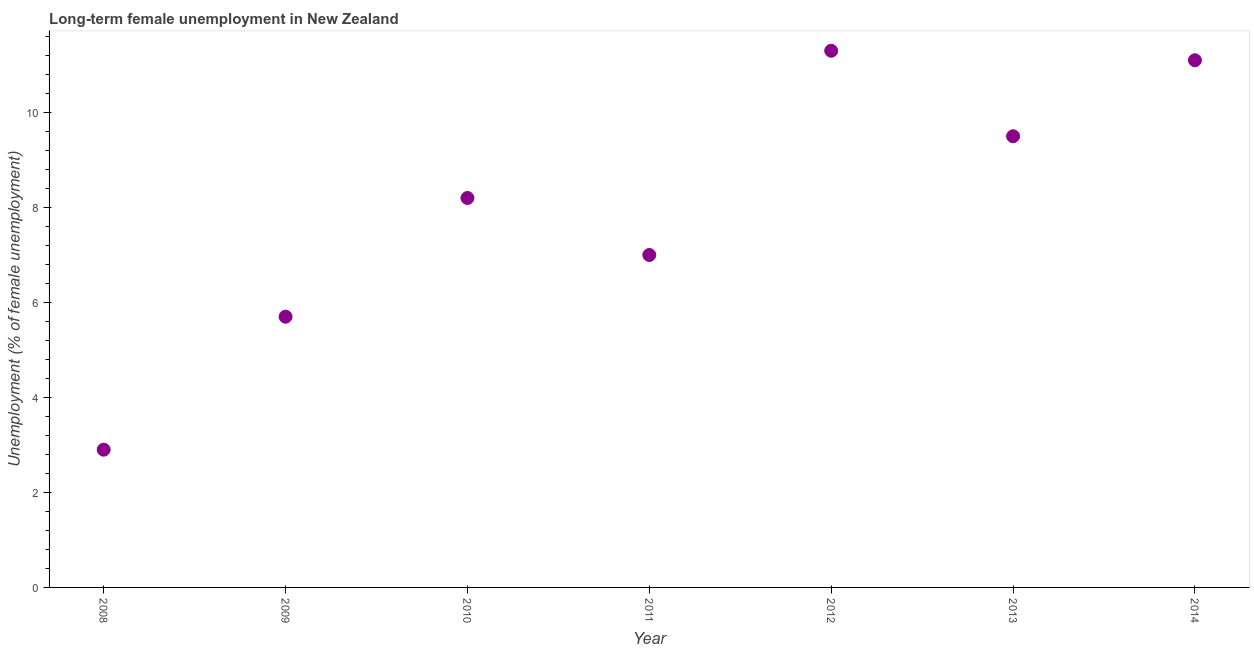What is the long-term female unemployment in 2013?
Your response must be concise. 9.5. Across all years, what is the maximum long-term female unemployment?
Offer a very short reply. 11.3. Across all years, what is the minimum long-term female unemployment?
Give a very brief answer. 2.9. In which year was the long-term female unemployment maximum?
Your answer should be compact. 2012. In which year was the long-term female unemployment minimum?
Give a very brief answer. 2008. What is the sum of the long-term female unemployment?
Provide a short and direct response. 55.7. What is the difference between the long-term female unemployment in 2012 and 2014?
Your response must be concise. 0.2. What is the average long-term female unemployment per year?
Make the answer very short. 7.96. What is the median long-term female unemployment?
Offer a very short reply. 8.2. Do a majority of the years between 2009 and 2011 (inclusive) have long-term female unemployment greater than 3.6 %?
Your answer should be very brief. Yes. What is the ratio of the long-term female unemployment in 2012 to that in 2014?
Your response must be concise. 1.02. Is the long-term female unemployment in 2009 less than that in 2011?
Your response must be concise. Yes. Is the difference between the long-term female unemployment in 2012 and 2014 greater than the difference between any two years?
Offer a terse response. No. What is the difference between the highest and the second highest long-term female unemployment?
Keep it short and to the point. 0.2. What is the difference between the highest and the lowest long-term female unemployment?
Make the answer very short. 8.4. Does the graph contain any zero values?
Your answer should be compact. No. Does the graph contain grids?
Ensure brevity in your answer.  No. What is the title of the graph?
Make the answer very short. Long-term female unemployment in New Zealand. What is the label or title of the Y-axis?
Provide a short and direct response. Unemployment (% of female unemployment). What is the Unemployment (% of female unemployment) in 2008?
Your answer should be compact. 2.9. What is the Unemployment (% of female unemployment) in 2009?
Offer a terse response. 5.7. What is the Unemployment (% of female unemployment) in 2010?
Provide a short and direct response. 8.2. What is the Unemployment (% of female unemployment) in 2012?
Your answer should be very brief. 11.3. What is the Unemployment (% of female unemployment) in 2014?
Offer a very short reply. 11.1. What is the difference between the Unemployment (% of female unemployment) in 2008 and 2009?
Your response must be concise. -2.8. What is the difference between the Unemployment (% of female unemployment) in 2008 and 2011?
Your response must be concise. -4.1. What is the difference between the Unemployment (% of female unemployment) in 2008 and 2012?
Give a very brief answer. -8.4. What is the difference between the Unemployment (% of female unemployment) in 2008 and 2013?
Keep it short and to the point. -6.6. What is the difference between the Unemployment (% of female unemployment) in 2009 and 2010?
Your response must be concise. -2.5. What is the difference between the Unemployment (% of female unemployment) in 2009 and 2011?
Offer a very short reply. -1.3. What is the difference between the Unemployment (% of female unemployment) in 2009 and 2013?
Offer a terse response. -3.8. What is the difference between the Unemployment (% of female unemployment) in 2009 and 2014?
Give a very brief answer. -5.4. What is the difference between the Unemployment (% of female unemployment) in 2010 and 2011?
Your answer should be compact. 1.2. What is the difference between the Unemployment (% of female unemployment) in 2010 and 2014?
Offer a terse response. -2.9. What is the difference between the Unemployment (% of female unemployment) in 2011 and 2012?
Your answer should be compact. -4.3. What is the difference between the Unemployment (% of female unemployment) in 2011 and 2013?
Keep it short and to the point. -2.5. What is the difference between the Unemployment (% of female unemployment) in 2011 and 2014?
Provide a succinct answer. -4.1. What is the ratio of the Unemployment (% of female unemployment) in 2008 to that in 2009?
Ensure brevity in your answer.  0.51. What is the ratio of the Unemployment (% of female unemployment) in 2008 to that in 2010?
Your answer should be compact. 0.35. What is the ratio of the Unemployment (% of female unemployment) in 2008 to that in 2011?
Ensure brevity in your answer.  0.41. What is the ratio of the Unemployment (% of female unemployment) in 2008 to that in 2012?
Ensure brevity in your answer.  0.26. What is the ratio of the Unemployment (% of female unemployment) in 2008 to that in 2013?
Keep it short and to the point. 0.3. What is the ratio of the Unemployment (% of female unemployment) in 2008 to that in 2014?
Ensure brevity in your answer.  0.26. What is the ratio of the Unemployment (% of female unemployment) in 2009 to that in 2010?
Offer a terse response. 0.69. What is the ratio of the Unemployment (% of female unemployment) in 2009 to that in 2011?
Your answer should be compact. 0.81. What is the ratio of the Unemployment (% of female unemployment) in 2009 to that in 2012?
Your response must be concise. 0.5. What is the ratio of the Unemployment (% of female unemployment) in 2009 to that in 2013?
Your response must be concise. 0.6. What is the ratio of the Unemployment (% of female unemployment) in 2009 to that in 2014?
Offer a terse response. 0.51. What is the ratio of the Unemployment (% of female unemployment) in 2010 to that in 2011?
Keep it short and to the point. 1.17. What is the ratio of the Unemployment (% of female unemployment) in 2010 to that in 2012?
Ensure brevity in your answer.  0.73. What is the ratio of the Unemployment (% of female unemployment) in 2010 to that in 2013?
Offer a very short reply. 0.86. What is the ratio of the Unemployment (% of female unemployment) in 2010 to that in 2014?
Your answer should be very brief. 0.74. What is the ratio of the Unemployment (% of female unemployment) in 2011 to that in 2012?
Your answer should be very brief. 0.62. What is the ratio of the Unemployment (% of female unemployment) in 2011 to that in 2013?
Provide a short and direct response. 0.74. What is the ratio of the Unemployment (% of female unemployment) in 2011 to that in 2014?
Provide a short and direct response. 0.63. What is the ratio of the Unemployment (% of female unemployment) in 2012 to that in 2013?
Your answer should be very brief. 1.19. What is the ratio of the Unemployment (% of female unemployment) in 2012 to that in 2014?
Your answer should be very brief. 1.02. What is the ratio of the Unemployment (% of female unemployment) in 2013 to that in 2014?
Give a very brief answer. 0.86. 